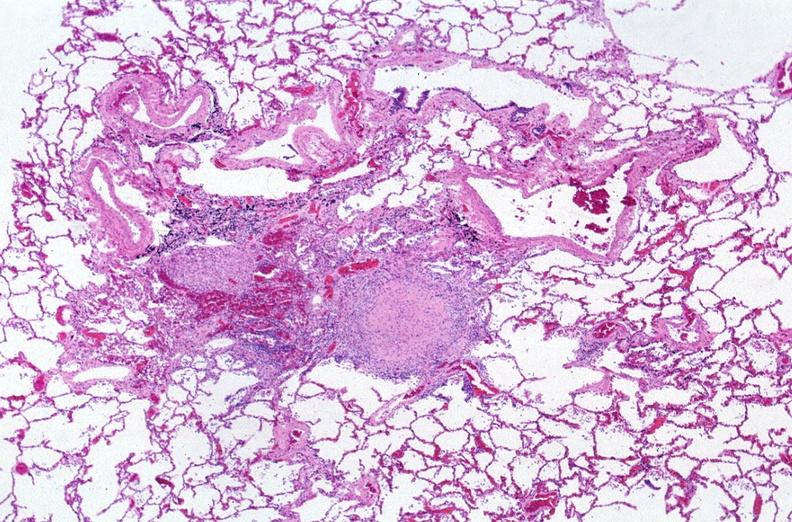s respiratory present?
Answer the question using a single word or phrase. Yes 